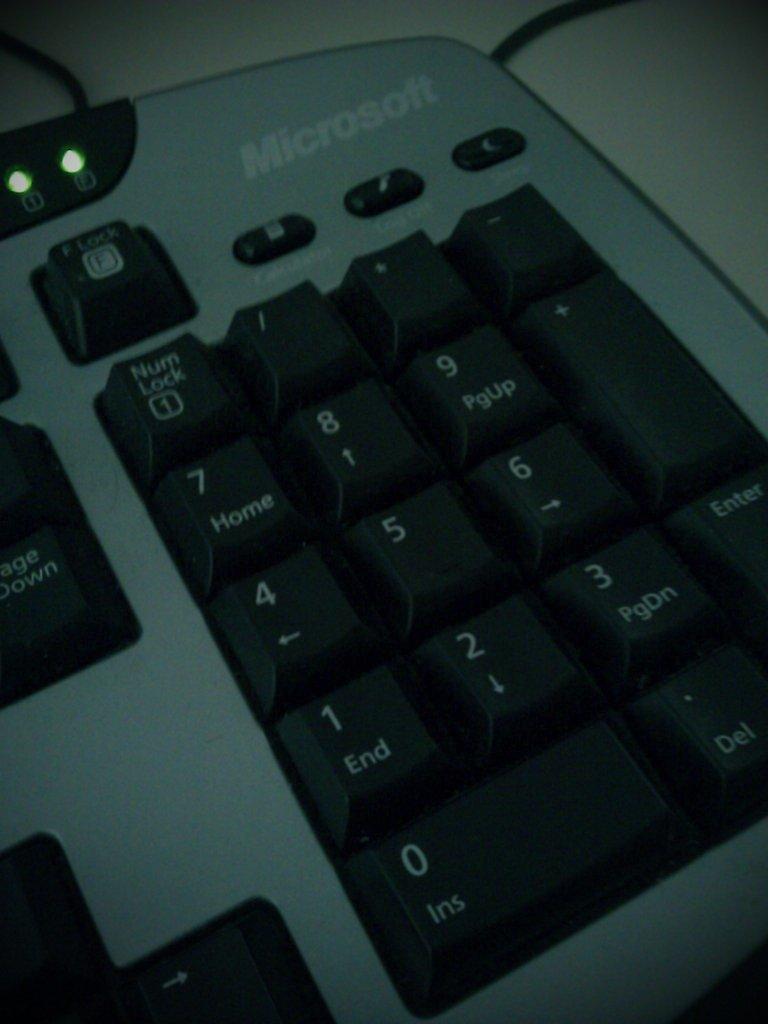What company is on the keyboard?
Offer a very short reply. Microsoft. 